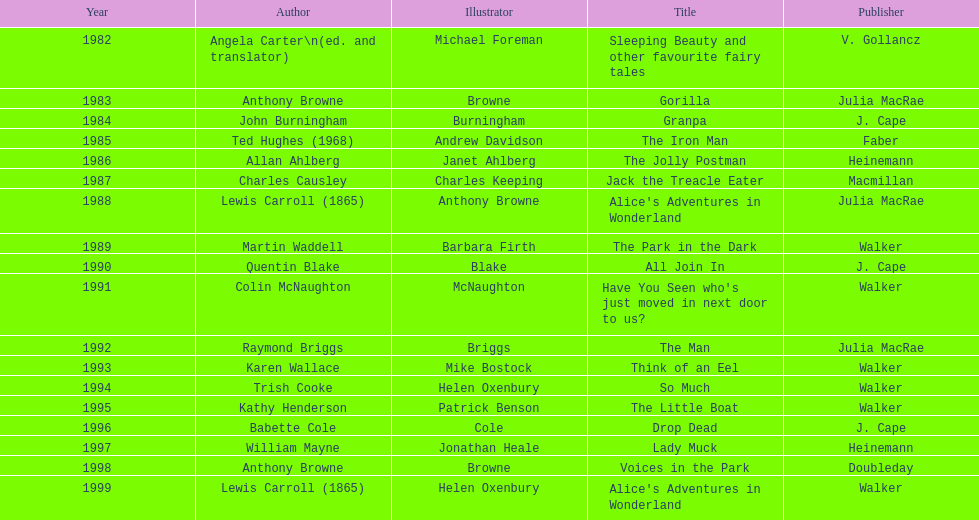Apart from lewis carroll, which other writer has received the kurt maschler award two times? Anthony Browne. 